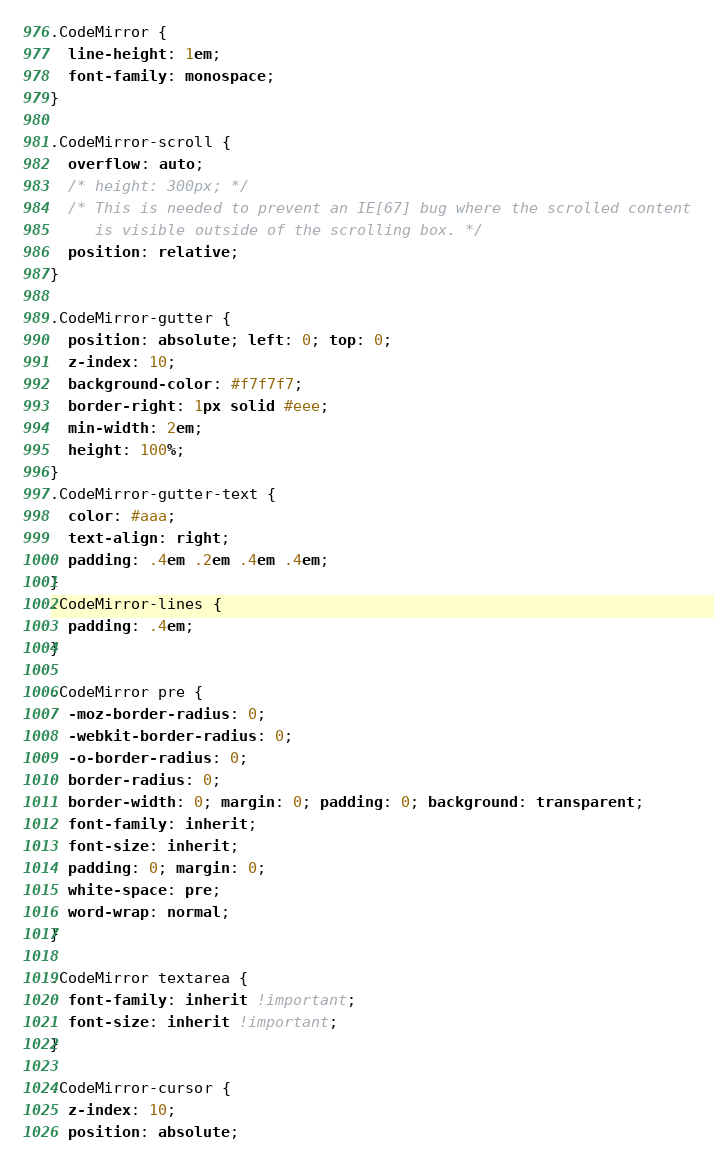<code> <loc_0><loc_0><loc_500><loc_500><_CSS_>.CodeMirror {
  line-height: 1em;
  font-family: monospace;
}

.CodeMirror-scroll {
  overflow: auto;
  /* height: 300px; */
  /* This is needed to prevent an IE[67] bug where the scrolled content
     is visible outside of the scrolling box. */
  position: relative;
}

.CodeMirror-gutter {
  position: absolute; left: 0; top: 0;
  z-index: 10;
  background-color: #f7f7f7;
  border-right: 1px solid #eee;
  min-width: 2em;
  height: 100%;
}
.CodeMirror-gutter-text {
  color: #aaa;
  text-align: right;
  padding: .4em .2em .4em .4em;
}
.CodeMirror-lines {
  padding: .4em;
}

.CodeMirror pre {
  -moz-border-radius: 0;
  -webkit-border-radius: 0;
  -o-border-radius: 0;
  border-radius: 0;
  border-width: 0; margin: 0; padding: 0; background: transparent;
  font-family: inherit;
  font-size: inherit;
  padding: 0; margin: 0;
  white-space: pre;
  word-wrap: normal;
}

.CodeMirror textarea {
  font-family: inherit !important;
  font-size: inherit !important;
}

.CodeMirror-cursor {
  z-index: 10;
  position: absolute;</code> 